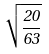Convert formula to latex. <formula><loc_0><loc_0><loc_500><loc_500>\sqrt { \frac { 2 0 } { 6 3 } }</formula> 